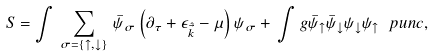<formula> <loc_0><loc_0><loc_500><loc_500>S = \int \, \sum _ { \sigma = \{ \uparrow , \downarrow \} } \, \bar { \psi } _ { \sigma } \left ( \partial _ { \tau } + \epsilon _ { \hat { \vec { k } } } - \mu \right ) \psi _ { \sigma } + \, \int g \bar { \psi } _ { \uparrow } \bar { \psi } _ { \downarrow } \psi _ { \downarrow } \psi _ { \uparrow } \ p u n c { , }</formula> 